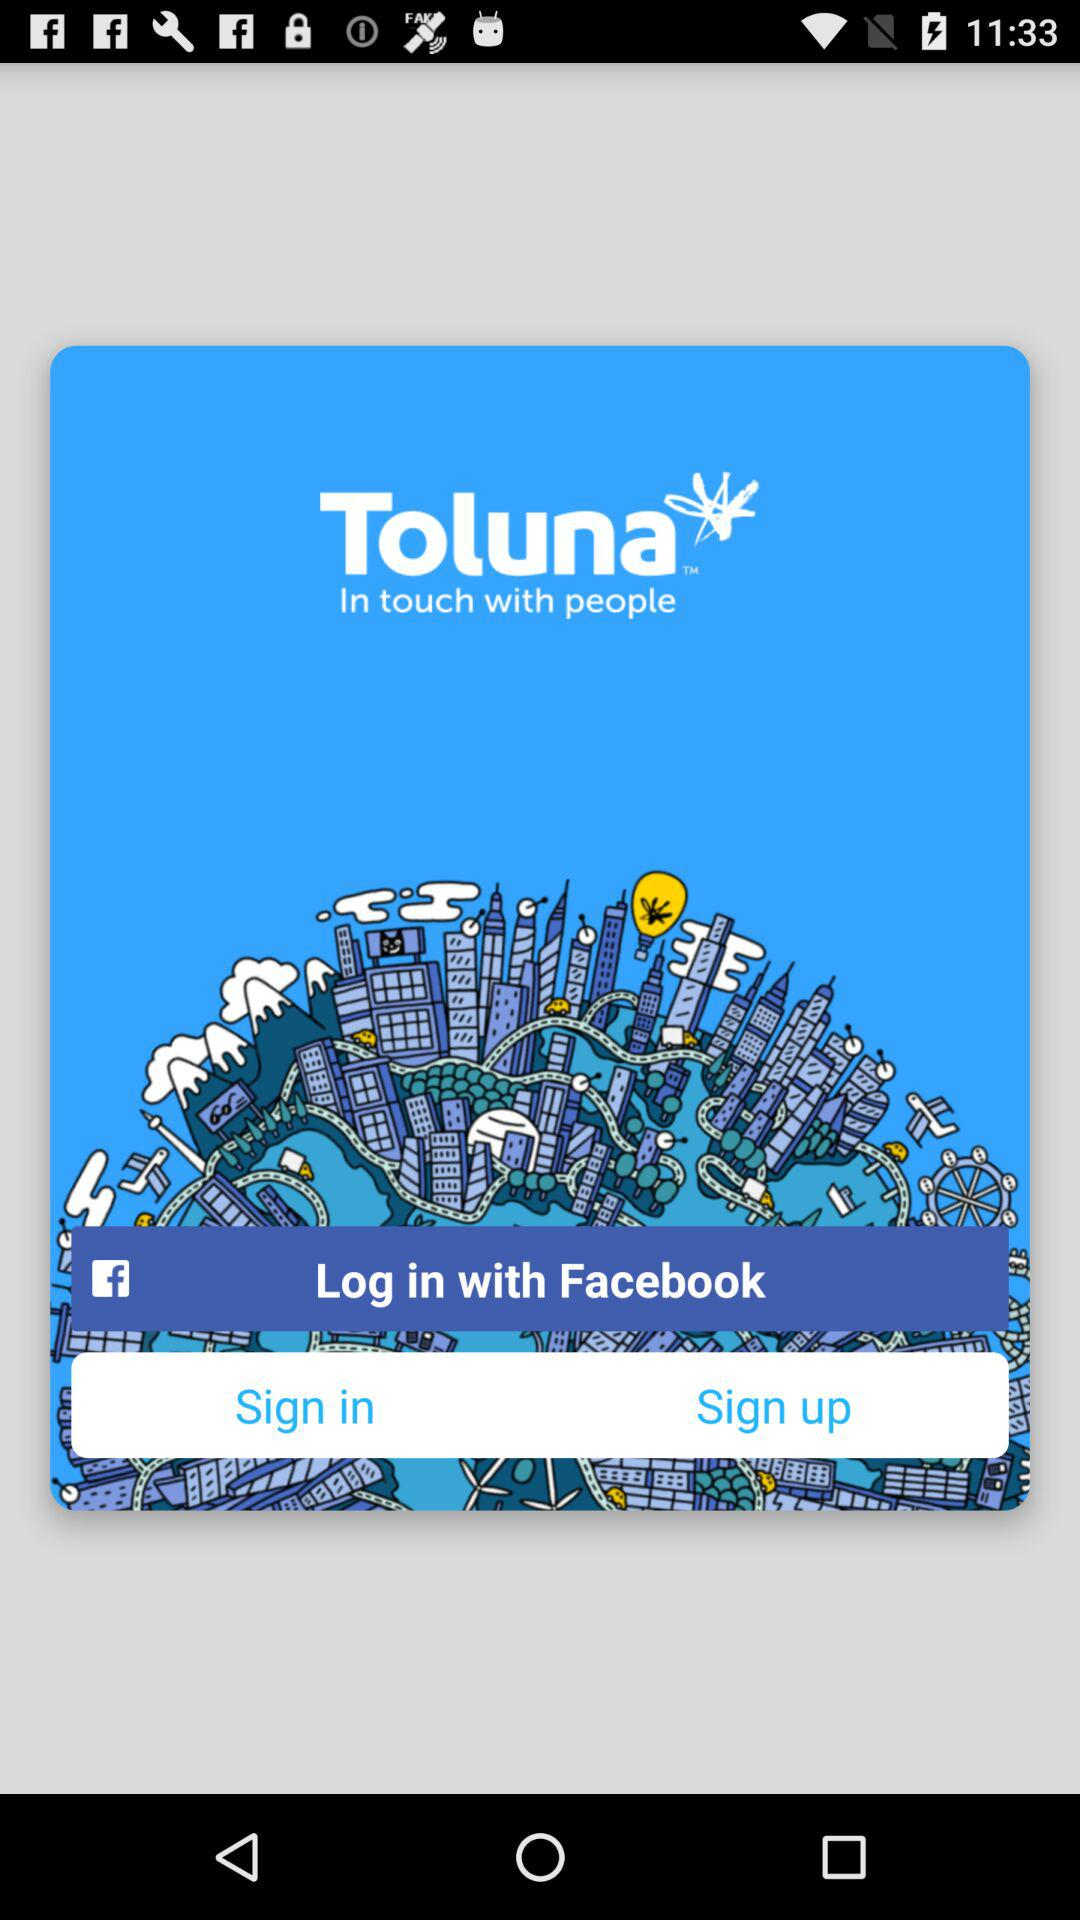Which apps can we log in with? You can log in with "Facebook". 